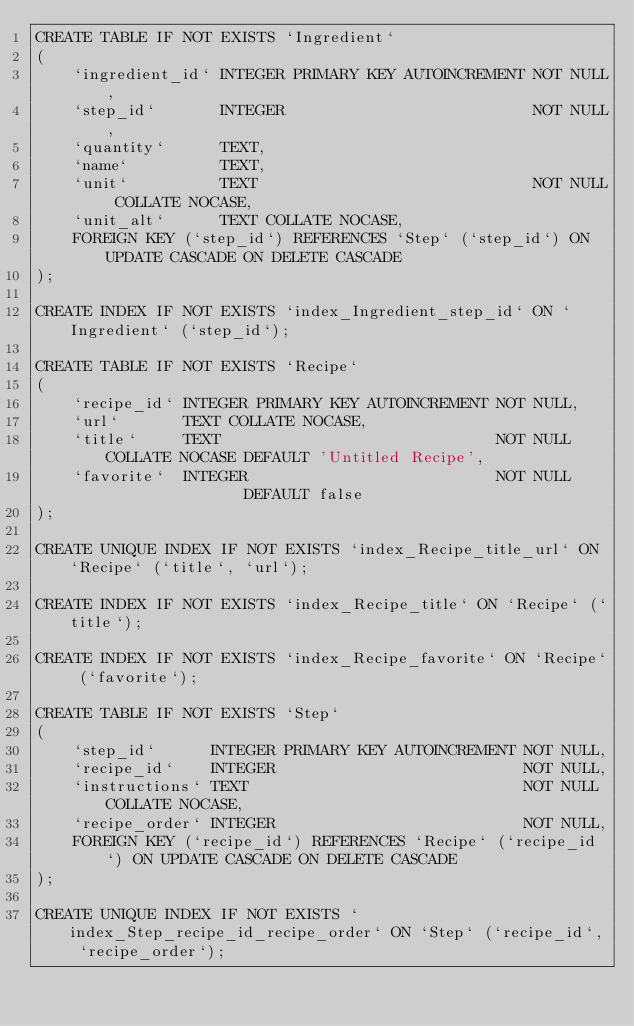<code> <loc_0><loc_0><loc_500><loc_500><_SQL_>CREATE TABLE IF NOT EXISTS `Ingredient`
(
    `ingredient_id` INTEGER PRIMARY KEY AUTOINCREMENT NOT NULL,
    `step_id`       INTEGER                           NOT NULL,
    `quantity`      TEXT,
    `name`          TEXT,
    `unit`          TEXT                              NOT NULL COLLATE NOCASE,
    `unit_alt`      TEXT COLLATE NOCASE,
    FOREIGN KEY (`step_id`) REFERENCES `Step` (`step_id`) ON UPDATE CASCADE ON DELETE CASCADE
);

CREATE INDEX IF NOT EXISTS `index_Ingredient_step_id` ON `Ingredient` (`step_id`);

CREATE TABLE IF NOT EXISTS `Recipe`
(
    `recipe_id` INTEGER PRIMARY KEY AUTOINCREMENT NOT NULL,
    `url`       TEXT COLLATE NOCASE,
    `title`     TEXT                              NOT NULL COLLATE NOCASE DEFAULT 'Untitled Recipe',
    `favorite`  INTEGER                           NOT NULL                DEFAULT false
);

CREATE UNIQUE INDEX IF NOT EXISTS `index_Recipe_title_url` ON `Recipe` (`title`, `url`);

CREATE INDEX IF NOT EXISTS `index_Recipe_title` ON `Recipe` (`title`);

CREATE INDEX IF NOT EXISTS `index_Recipe_favorite` ON `Recipe` (`favorite`);

CREATE TABLE IF NOT EXISTS `Step`
(
    `step_id`      INTEGER PRIMARY KEY AUTOINCREMENT NOT NULL,
    `recipe_id`    INTEGER                           NOT NULL,
    `instructions` TEXT                              NOT NULL COLLATE NOCASE,
    `recipe_order` INTEGER                           NOT NULL,
    FOREIGN KEY (`recipe_id`) REFERENCES `Recipe` (`recipe_id`) ON UPDATE CASCADE ON DELETE CASCADE
);

CREATE UNIQUE INDEX IF NOT EXISTS `index_Step_recipe_id_recipe_order` ON `Step` (`recipe_id`, `recipe_order`);</code> 